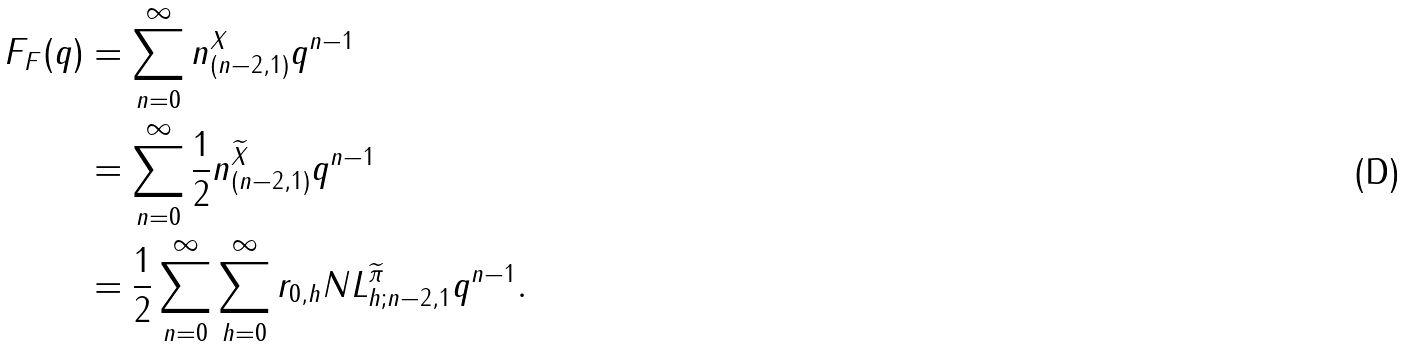<formula> <loc_0><loc_0><loc_500><loc_500>F _ { F } ( q ) & = \sum _ { n = 0 } ^ { \infty } n _ { ( n - 2 , 1 ) } ^ { X } q ^ { n - 1 } \\ & = \sum _ { n = 0 } ^ { \infty } \frac { 1 } { 2 } n _ { ( n - 2 , 1 ) } ^ { \widetilde { X } } q ^ { n - 1 } \\ & = \frac { 1 } { 2 } \sum _ { n = 0 } ^ { \infty } \sum _ { h = 0 } ^ { \infty } r _ { 0 , h } N L _ { h ; n - 2 , 1 } ^ { \widetilde { \pi } } q ^ { n - 1 } .</formula> 